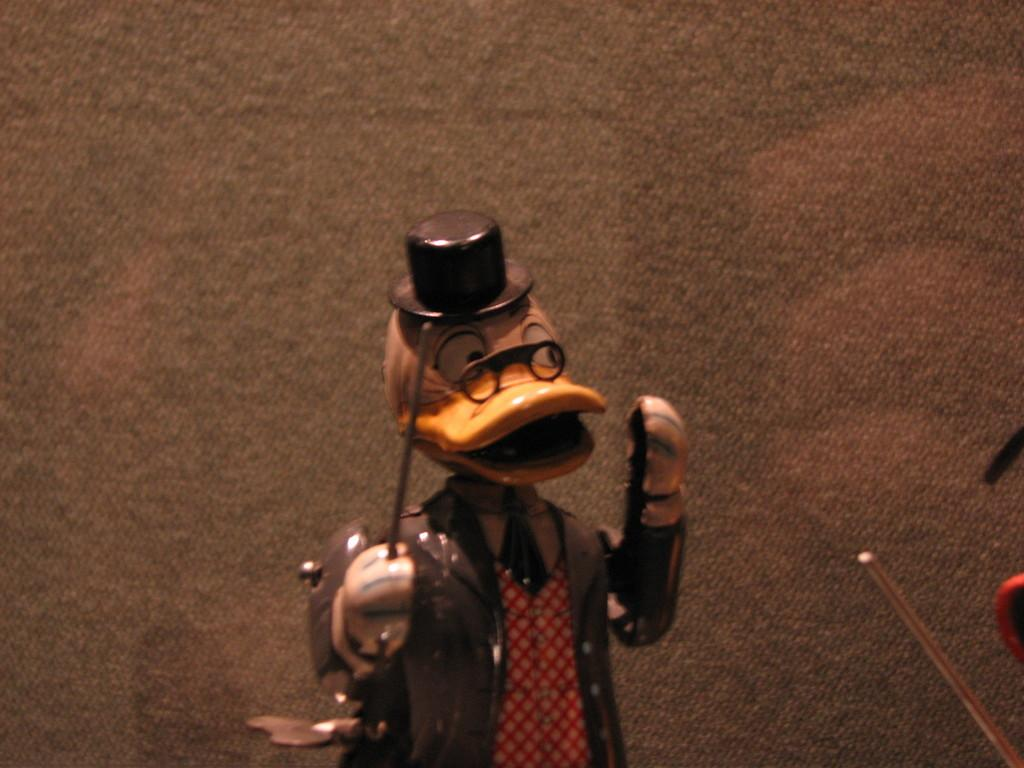What is the main subject of the image? There is a sculpture of a cartoon character in the image. What is the cartoon character wearing? The cartoon character is wearing a hat. What is the cartoon character holding? The cartoon character is holding a stick. What other objects can be seen in the image? There are other objects visible in the image. What account number is associated with the pencil in the image? There is no pencil present in the image, and therefore no account number can be associated with it. 